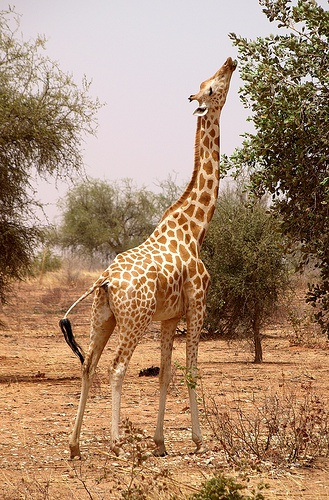Describe the objects in this image and their specific colors. I can see a giraffe in lightgray, brown, gray, tan, and maroon tones in this image. 